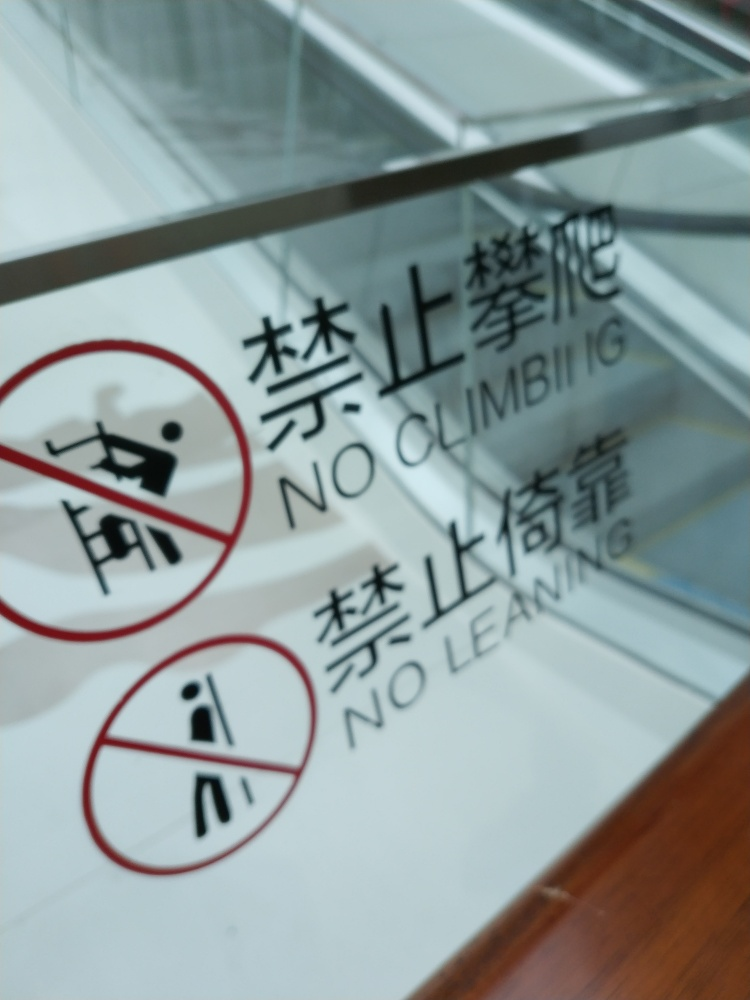Can the sign's message be understood universally? Yes, the sign's use of pictograms with universally understood symbols (a person doing an action with a red slash through it) bordered with a bold red line indicates prohibition and is designed to convey the message without relying on language. This visual communication aids in crossing language barriers, and the written warnings in English support understanding for English speakers as well. 